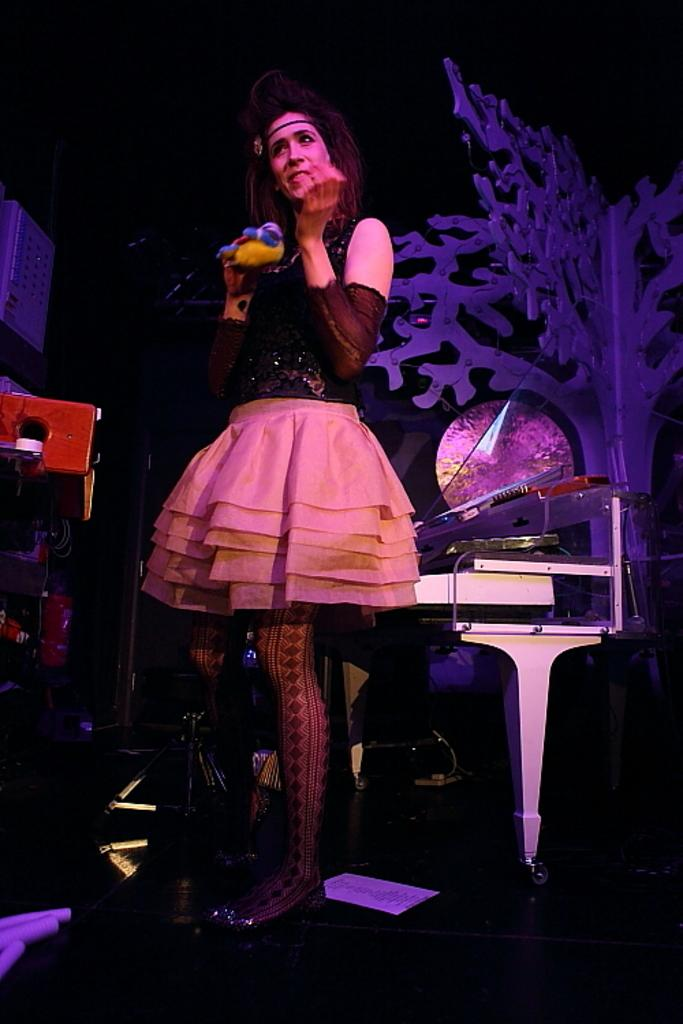What is the main subject of the image? There is a man standing in the image. What can be seen in the background of the image? There are musical instruments in the background of the image. What type of object is present in the image that is not a natural tree? There is an artificial tree in the image. How many houses are visible in the image? There are no houses visible in the image. What type of control does the man have over the musical instruments in the image? The image does not show the man interacting with the musical instruments, so it cannot be determined if he has any control over them. 